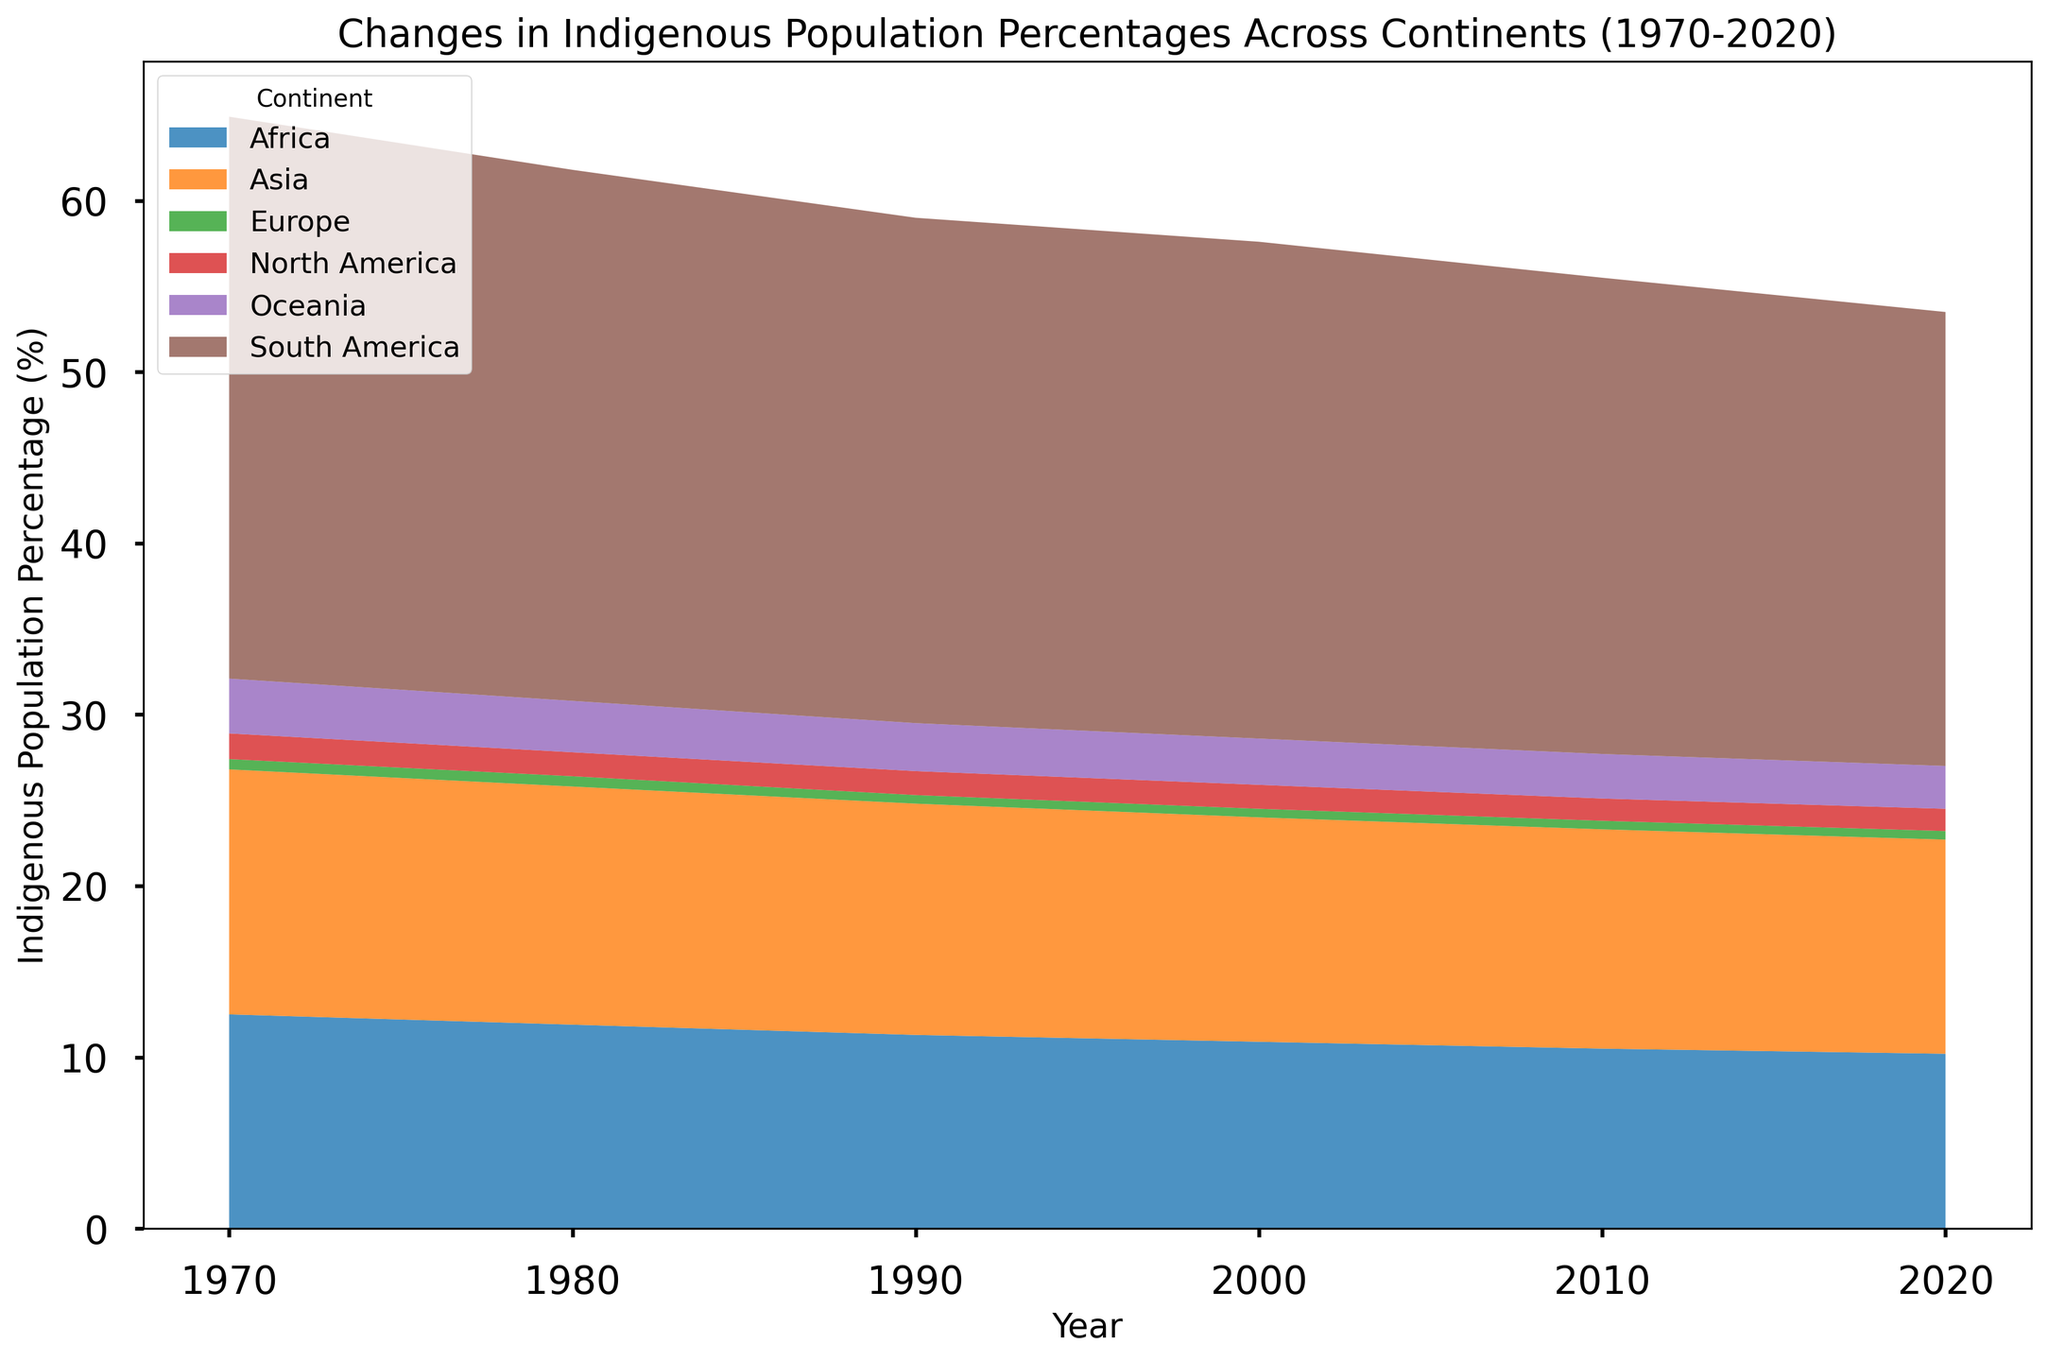Which continent had the highest indigenous population percentage in 1970? To find this, look at the height of the colored area representing each continent at the year 1970. The tallest colored section at the year 1970 indicates South America.
Answer: South America How did the indigenous population percentage in Oceania change from 1970 to 2020? Observe the height of the colored area representing Oceania at both the years 1970 and 2020. It decreased from 3.2% to 2.5%.
Answer: Decreased Which continent saw the largest absolute decrease in indigenous population percentage between 1970 and 2020? Calculate the difference between the two years for all continents. South America showed a decrease from 32.8% to 26.5%, which is the largest absolute difference.
Answer: South America Compare the indigenous population percentages in North America and Europe in 2020. Which continent had a higher percentage? Check the height of the colored areas representing North America and Europe at the year 2020. North America had 1.3% whereas Europe had 0.5%.
Answer: North America What trend can be observed in the indigenous population percentages across all continents over 50 years? Look at the general direction of the height of the areas representing each continent from 1970 to 2020. All continents show a declining trend.
Answer: Declining trend What is the sum of the indigenous population percentages in Asia and Africa in 2020? Add the percentages for Asia (12.5%) and Africa (10.2%) in 2020. 12.5 + 10.2 = 22.7
Answer: 22.7 How did the indigenous population percentage in Africa change between 1980 and 1990? Look at the height of the colored area representing Africa for the years 1980 (11.9) and 1990 (11.3). The percentage decreased by 0.6.
Answer: Decreased by 0.6 Which continent's indigenous population percentage remained constant during any decade within the 50-year span? Observe the height of colored areas for each continent over each decade. Europe’s percentage stayed constant at 0.5% from 1990 to 2020.
Answer: Europe In 1990, which two continents had the closest indigenous population percentages, and what were those percentages? Compare the heights of colored areas in 1990. North America (1.4%) and Oceania (2.8%) have the closest, with a difference of 1.4%.
Answer: North America and Oceania, 1.4% and 2.8% For the year 2000, calculate the average indigenous population percentage across all continents. Sum all percentages for the year 2000 and divide by the number of continents. (10.9 + 13.1 + 0.5 + 1.4 + 29.0 + 2.7) / 6 = 9.6
Answer: 9.6 